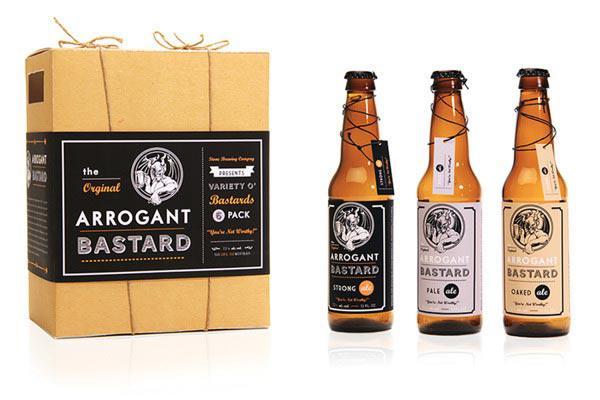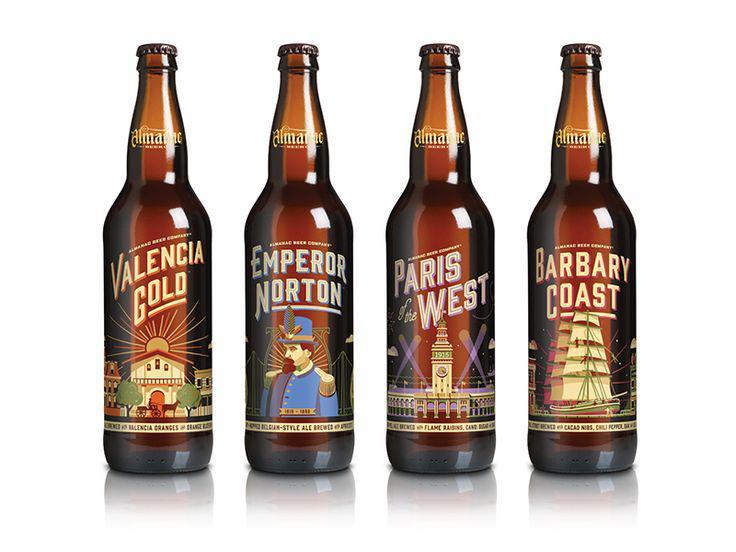The first image is the image on the left, the second image is the image on the right. Given the left and right images, does the statement "There are only two bottle visible in the right image." hold true? Answer yes or no. No. The first image is the image on the left, the second image is the image on the right. Given the left and right images, does the statement "In at least one image there are three bottles in a cardboard six pack holder." hold true? Answer yes or no. No. 